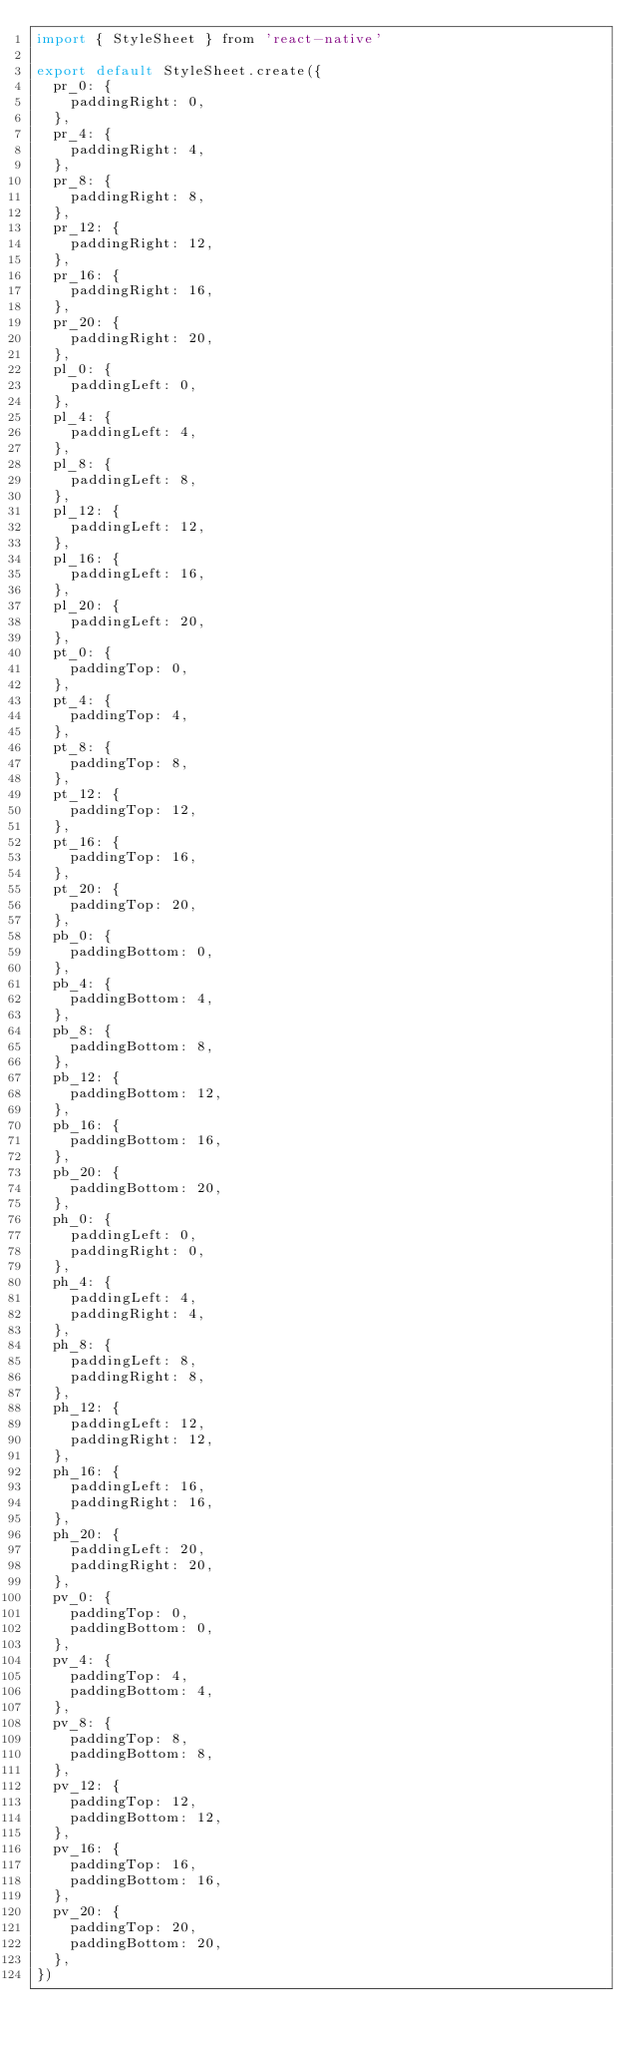<code> <loc_0><loc_0><loc_500><loc_500><_JavaScript_>import { StyleSheet } from 'react-native'

export default StyleSheet.create({
  pr_0: {
    paddingRight: 0,
  },
  pr_4: {
    paddingRight: 4,
  },
  pr_8: {
    paddingRight: 8,
  },
  pr_12: {
    paddingRight: 12,
  },
  pr_16: {
    paddingRight: 16,
  },
  pr_20: {
    paddingRight: 20,
  },
  pl_0: {
    paddingLeft: 0,
  },
  pl_4: {
    paddingLeft: 4,
  },
  pl_8: {
    paddingLeft: 8,
  },
  pl_12: {
    paddingLeft: 12,
  },
  pl_16: {
    paddingLeft: 16,
  },
  pl_20: {
    paddingLeft: 20,
  },
  pt_0: {
    paddingTop: 0,
  },
  pt_4: {
    paddingTop: 4,
  },
  pt_8: {
    paddingTop: 8,
  },
  pt_12: {
    paddingTop: 12,
  },
  pt_16: {
    paddingTop: 16,
  },
  pt_20: {
    paddingTop: 20,
  },
  pb_0: {
    paddingBottom: 0,
  },
  pb_4: {
    paddingBottom: 4,
  },
  pb_8: {
    paddingBottom: 8,
  },
  pb_12: {
    paddingBottom: 12,
  },
  pb_16: {
    paddingBottom: 16,
  },
  pb_20: {
    paddingBottom: 20,
  },
  ph_0: {
    paddingLeft: 0,
    paddingRight: 0,
  },
  ph_4: {
    paddingLeft: 4,
    paddingRight: 4,
  },
  ph_8: {
    paddingLeft: 8,
    paddingRight: 8,
  },
  ph_12: {
    paddingLeft: 12,
    paddingRight: 12,
  },
  ph_16: {
    paddingLeft: 16,
    paddingRight: 16,
  },
  ph_20: {
    paddingLeft: 20,
    paddingRight: 20,
  },
  pv_0: {
    paddingTop: 0,
    paddingBottom: 0,
  },
  pv_4: {
    paddingTop: 4,
    paddingBottom: 4,
  },
  pv_8: {
    paddingTop: 8,
    paddingBottom: 8,
  },
  pv_12: {
    paddingTop: 12,
    paddingBottom: 12,
  },
  pv_16: {
    paddingTop: 16,
    paddingBottom: 16,
  },
  pv_20: {
    paddingTop: 20,
    paddingBottom: 20,
  },
})
</code> 